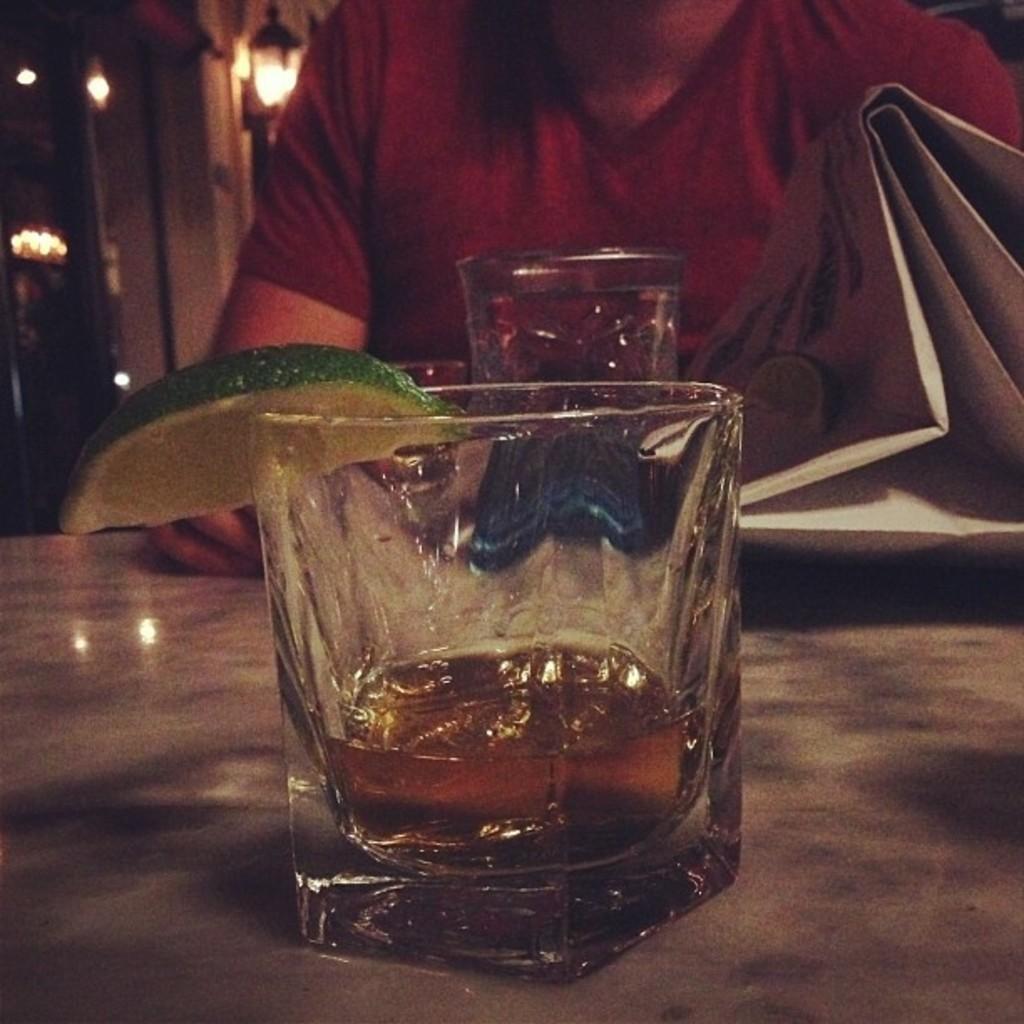In one or two sentences, can you explain what this image depicts? In this image in front there is a glass with wine in it and there is a slice of a lemon. Behind the glass there is another glass on the table. In front of the table there is a person. In front of him there is some object. In the background of the image there are lights. 